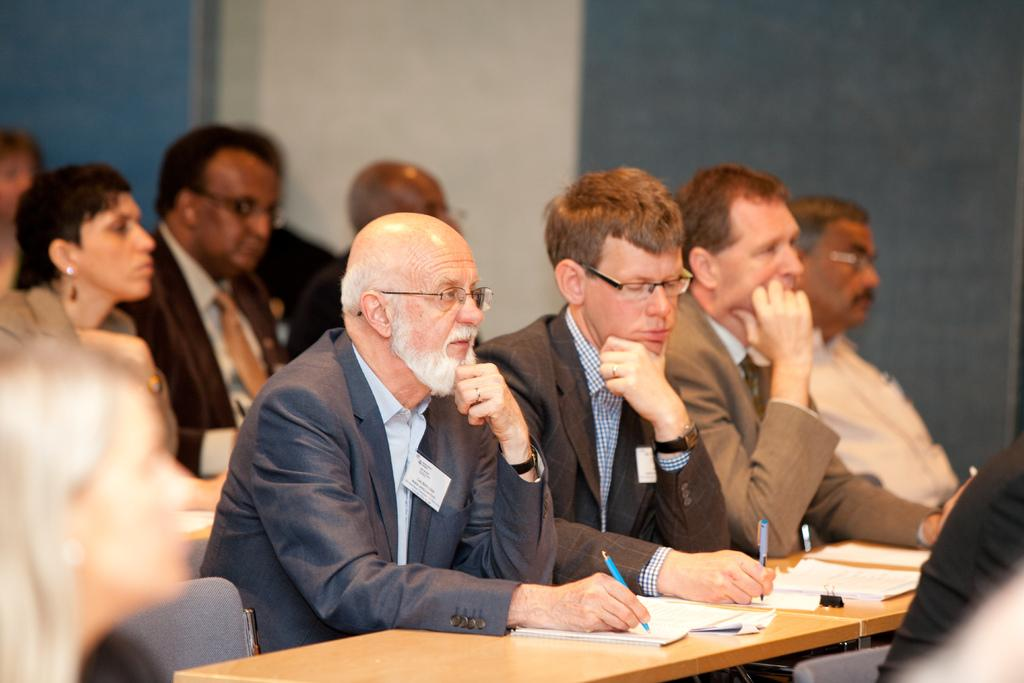What are the people in the image doing? There is a group of people sitting in the image. What can be seen on the table in the image? There are objects on a table in the image. What is visible in the background of the image? There is a wall visible in the background of the image. How many icicles are hanging from the actor's page in the image? There is no actor or page present in the image, and therefore no icicles can be observed hanging from them. 